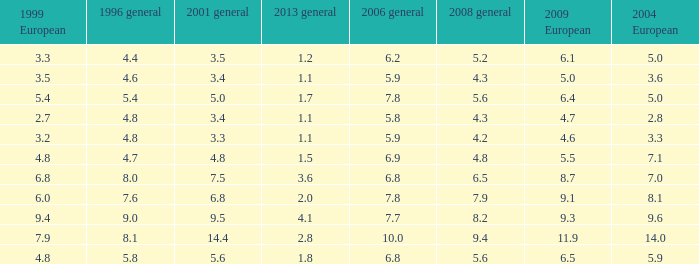How many values for 1999 European correspond to a value more than 4.7 in 2009 European, general 2001 more than 7.5, 2006 general at 10, and more than 9.4 in general 2008? 0.0. 